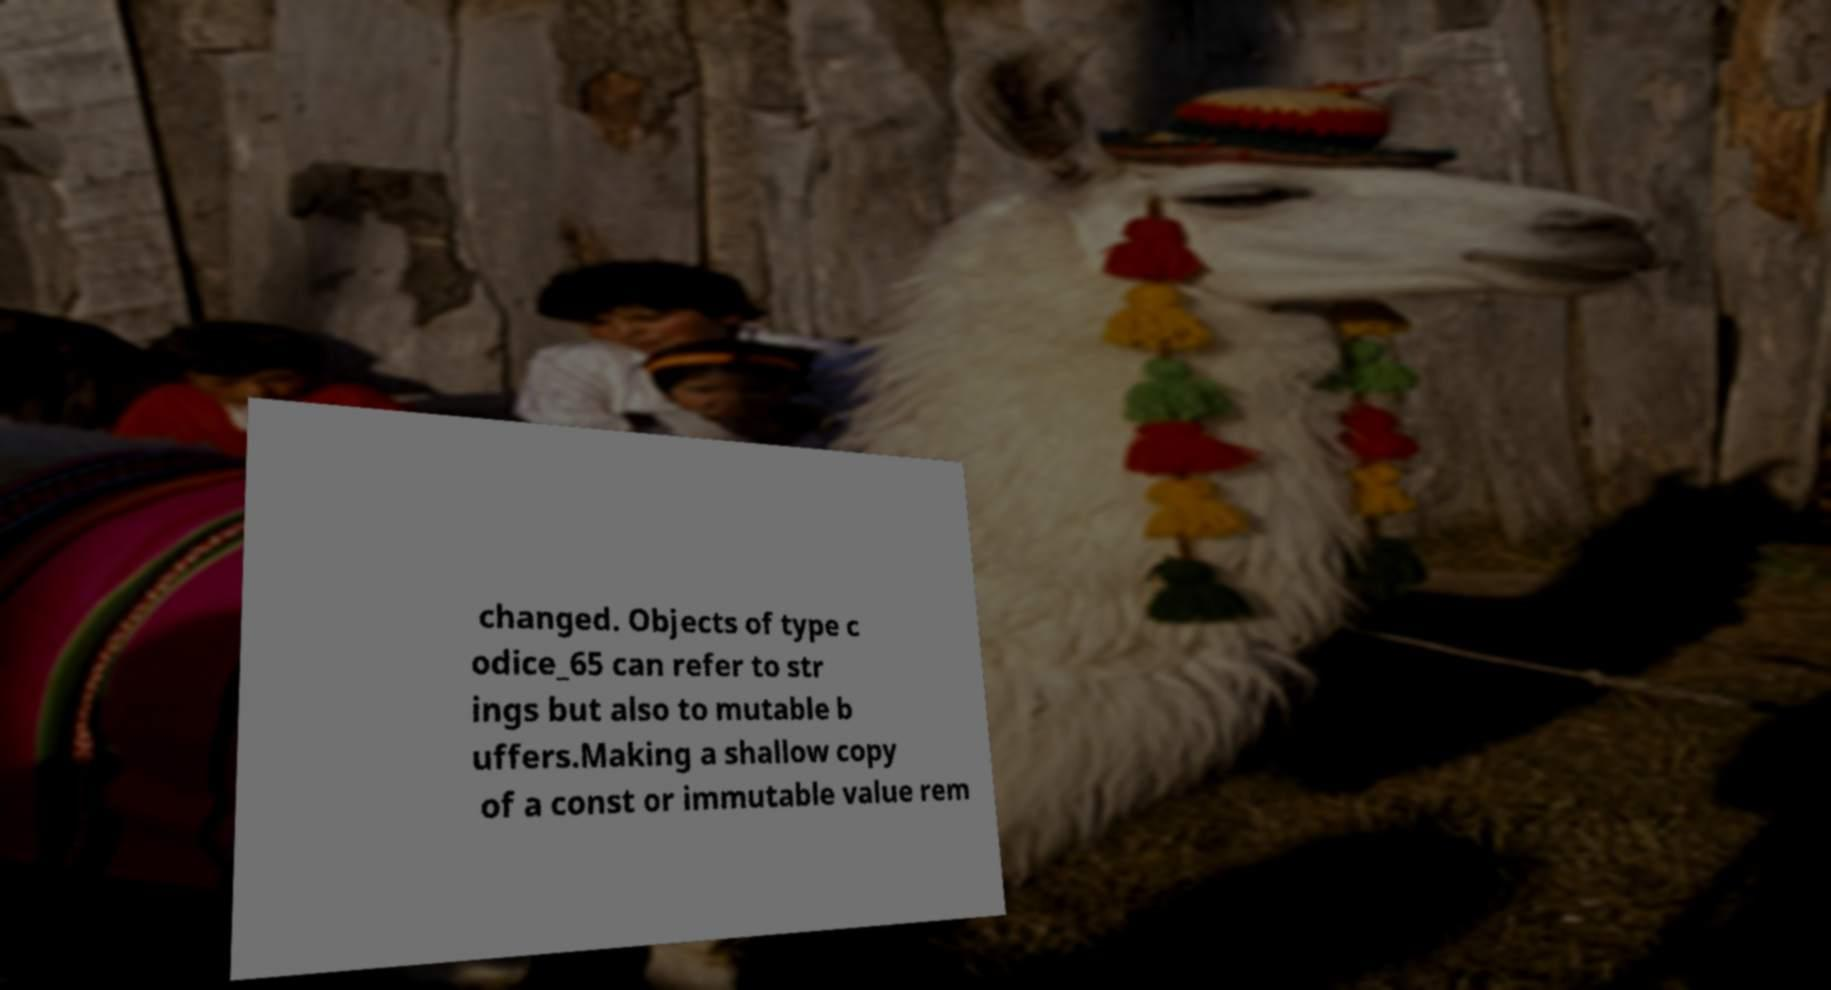What messages or text are displayed in this image? I need them in a readable, typed format. changed. Objects of type c odice_65 can refer to str ings but also to mutable b uffers.Making a shallow copy of a const or immutable value rem 